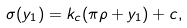<formula> <loc_0><loc_0><loc_500><loc_500>\sigma ( y _ { 1 } ) = k _ { c } ( \pi \rho + y _ { 1 } ) + c , \,</formula> 